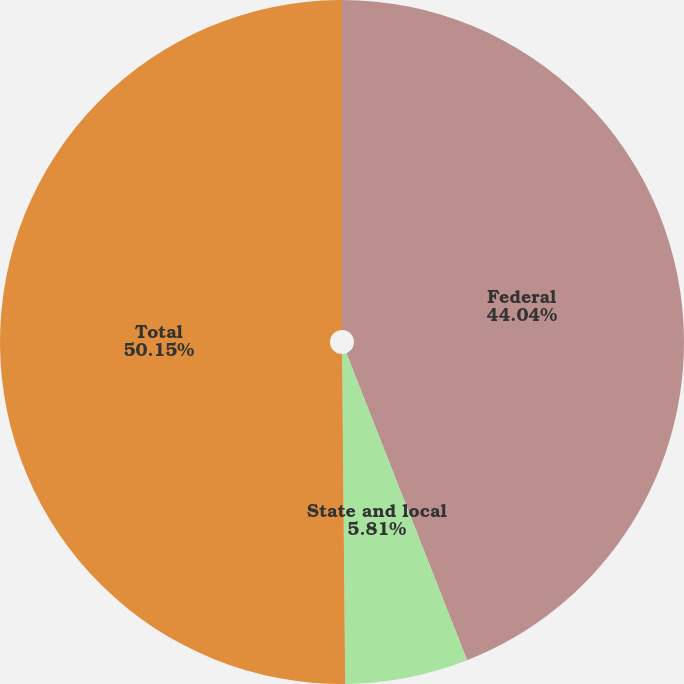Convert chart to OTSL. <chart><loc_0><loc_0><loc_500><loc_500><pie_chart><fcel>Federal<fcel>State and local<fcel>Total<nl><fcel>44.04%<fcel>5.81%<fcel>50.15%<nl></chart> 